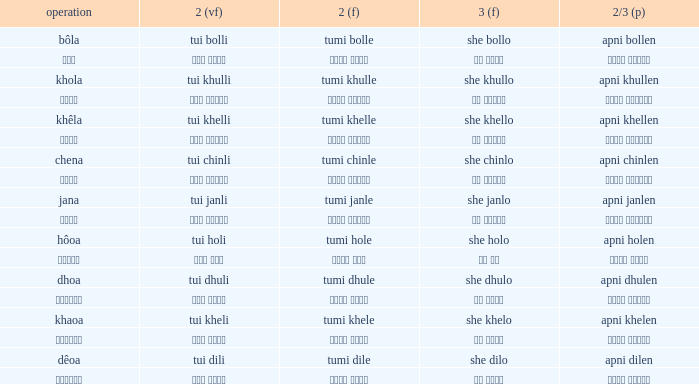What is the 2nd verb for Khola? Tumi khulle. 